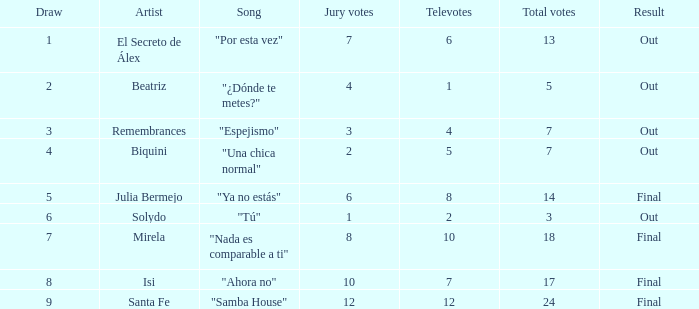Name the number of song for julia bermejo 1.0. Help me parse the entirety of this table. {'header': ['Draw', 'Artist', 'Song', 'Jury votes', 'Televotes', 'Total votes', 'Result'], 'rows': [['1', 'El Secreto de Álex', '"Por esta vez"', '7', '6', '13', 'Out'], ['2', 'Beatriz', '"¿Dónde te metes?"', '4', '1', '5', 'Out'], ['3', 'Remembrances', '"Espejismo"', '3', '4', '7', 'Out'], ['4', 'Biquini', '"Una chica normal"', '2', '5', '7', 'Out'], ['5', 'Julia Bermejo', '"Ya no estás"', '6', '8', '14', 'Final'], ['6', 'Solydo', '"Tú"', '1', '2', '3', 'Out'], ['7', 'Mirela', '"Nada es comparable a ti"', '8', '10', '18', 'Final'], ['8', 'Isi', '"Ahora no"', '10', '7', '17', 'Final'], ['9', 'Santa Fe', '"Samba House"', '12', '12', '24', 'Final']]} 